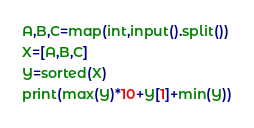Convert code to text. <code><loc_0><loc_0><loc_500><loc_500><_Python_>A,B,C=map(int,input().split())
X=[A,B,C]
Y=sorted(X)
print(max(Y)*10+Y[1]+min(Y))
</code> 